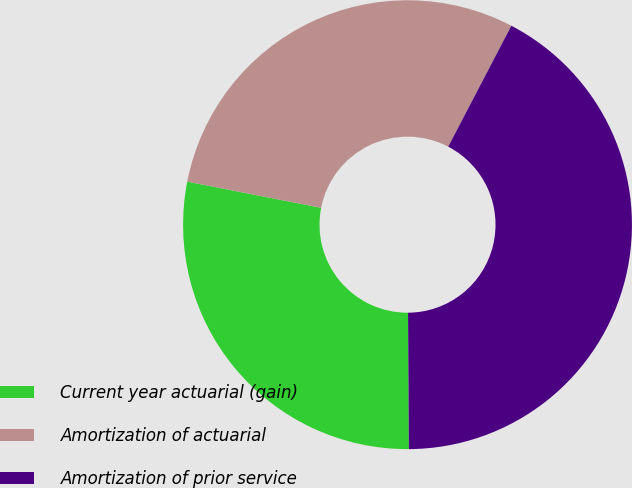Convert chart to OTSL. <chart><loc_0><loc_0><loc_500><loc_500><pie_chart><fcel>Current year actuarial (gain)<fcel>Amortization of actuarial<fcel>Amortization of prior service<nl><fcel>28.17%<fcel>29.58%<fcel>42.25%<nl></chart> 